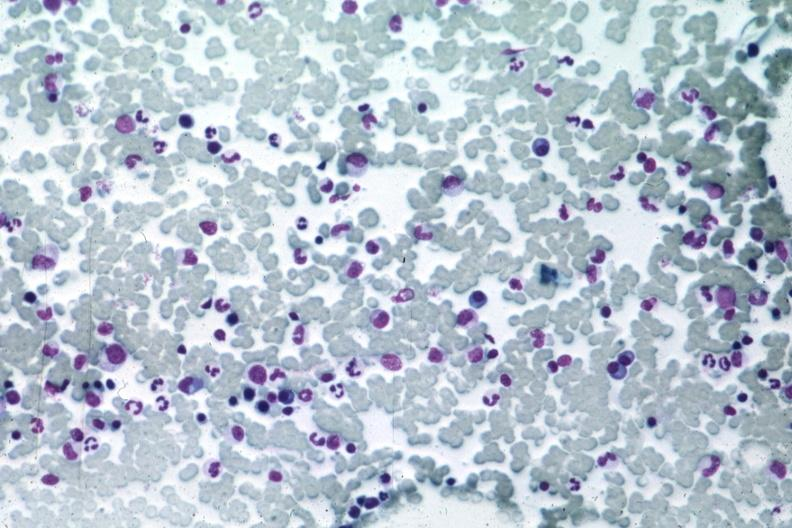s bone marrow present?
Answer the question using a single word or phrase. Yes 